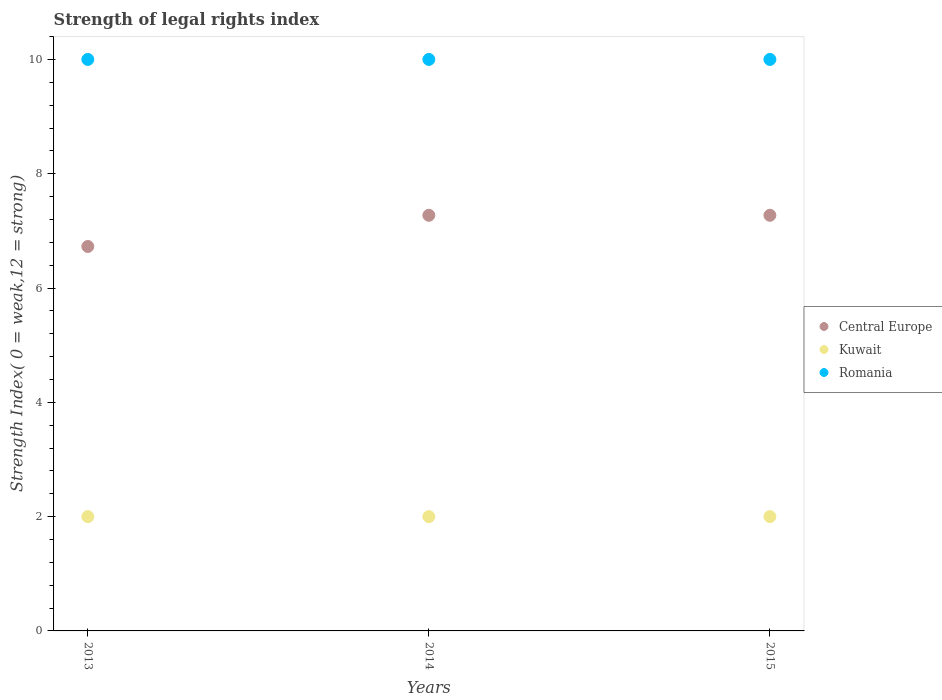What is the strength index in Central Europe in 2014?
Your response must be concise. 7.27. Across all years, what is the maximum strength index in Romania?
Provide a short and direct response. 10. Across all years, what is the minimum strength index in Romania?
Provide a short and direct response. 10. In which year was the strength index in Central Europe maximum?
Ensure brevity in your answer.  2014. What is the total strength index in Central Europe in the graph?
Your response must be concise. 21.27. What is the difference between the strength index in Romania in 2013 and that in 2015?
Your answer should be very brief. 0. What is the difference between the strength index in Kuwait in 2015 and the strength index in Romania in 2013?
Make the answer very short. -8. What is the average strength index in Kuwait per year?
Your answer should be compact. 2. In the year 2015, what is the difference between the strength index in Romania and strength index in Kuwait?
Provide a short and direct response. 8. What is the ratio of the strength index in Romania in 2014 to that in 2015?
Provide a succinct answer. 1. What is the difference between the highest and the second highest strength index in Kuwait?
Keep it short and to the point. 0. What is the difference between the highest and the lowest strength index in Romania?
Offer a terse response. 0. Is the sum of the strength index in Romania in 2013 and 2015 greater than the maximum strength index in Central Europe across all years?
Provide a succinct answer. Yes. Does the strength index in Kuwait monotonically increase over the years?
Provide a succinct answer. No. How many dotlines are there?
Give a very brief answer. 3. How many years are there in the graph?
Make the answer very short. 3. What is the difference between two consecutive major ticks on the Y-axis?
Offer a very short reply. 2. Does the graph contain grids?
Offer a very short reply. No. Where does the legend appear in the graph?
Provide a succinct answer. Center right. How are the legend labels stacked?
Your answer should be compact. Vertical. What is the title of the graph?
Make the answer very short. Strength of legal rights index. Does "Ecuador" appear as one of the legend labels in the graph?
Your answer should be compact. No. What is the label or title of the Y-axis?
Ensure brevity in your answer.  Strength Index( 0 = weak,12 = strong). What is the Strength Index( 0 = weak,12 = strong) in Central Europe in 2013?
Ensure brevity in your answer.  6.73. What is the Strength Index( 0 = weak,12 = strong) of Kuwait in 2013?
Ensure brevity in your answer.  2. What is the Strength Index( 0 = weak,12 = strong) of Central Europe in 2014?
Ensure brevity in your answer.  7.27. What is the Strength Index( 0 = weak,12 = strong) of Romania in 2014?
Keep it short and to the point. 10. What is the Strength Index( 0 = weak,12 = strong) in Central Europe in 2015?
Your answer should be compact. 7.27. Across all years, what is the maximum Strength Index( 0 = weak,12 = strong) in Central Europe?
Your answer should be compact. 7.27. Across all years, what is the maximum Strength Index( 0 = weak,12 = strong) in Romania?
Your answer should be compact. 10. Across all years, what is the minimum Strength Index( 0 = weak,12 = strong) of Central Europe?
Offer a very short reply. 6.73. Across all years, what is the minimum Strength Index( 0 = weak,12 = strong) in Kuwait?
Offer a very short reply. 2. Across all years, what is the minimum Strength Index( 0 = weak,12 = strong) of Romania?
Your answer should be compact. 10. What is the total Strength Index( 0 = weak,12 = strong) of Central Europe in the graph?
Give a very brief answer. 21.27. What is the total Strength Index( 0 = weak,12 = strong) of Kuwait in the graph?
Provide a succinct answer. 6. What is the difference between the Strength Index( 0 = weak,12 = strong) of Central Europe in 2013 and that in 2014?
Give a very brief answer. -0.55. What is the difference between the Strength Index( 0 = weak,12 = strong) in Kuwait in 2013 and that in 2014?
Provide a short and direct response. 0. What is the difference between the Strength Index( 0 = weak,12 = strong) of Romania in 2013 and that in 2014?
Offer a very short reply. 0. What is the difference between the Strength Index( 0 = weak,12 = strong) of Central Europe in 2013 and that in 2015?
Your answer should be compact. -0.55. What is the difference between the Strength Index( 0 = weak,12 = strong) in Central Europe in 2014 and that in 2015?
Provide a short and direct response. 0. What is the difference between the Strength Index( 0 = weak,12 = strong) of Central Europe in 2013 and the Strength Index( 0 = weak,12 = strong) of Kuwait in 2014?
Your answer should be compact. 4.73. What is the difference between the Strength Index( 0 = weak,12 = strong) in Central Europe in 2013 and the Strength Index( 0 = weak,12 = strong) in Romania in 2014?
Provide a succinct answer. -3.27. What is the difference between the Strength Index( 0 = weak,12 = strong) in Central Europe in 2013 and the Strength Index( 0 = weak,12 = strong) in Kuwait in 2015?
Your answer should be compact. 4.73. What is the difference between the Strength Index( 0 = weak,12 = strong) of Central Europe in 2013 and the Strength Index( 0 = weak,12 = strong) of Romania in 2015?
Give a very brief answer. -3.27. What is the difference between the Strength Index( 0 = weak,12 = strong) in Kuwait in 2013 and the Strength Index( 0 = weak,12 = strong) in Romania in 2015?
Your answer should be compact. -8. What is the difference between the Strength Index( 0 = weak,12 = strong) of Central Europe in 2014 and the Strength Index( 0 = weak,12 = strong) of Kuwait in 2015?
Your response must be concise. 5.27. What is the difference between the Strength Index( 0 = weak,12 = strong) of Central Europe in 2014 and the Strength Index( 0 = weak,12 = strong) of Romania in 2015?
Provide a short and direct response. -2.73. What is the difference between the Strength Index( 0 = weak,12 = strong) of Kuwait in 2014 and the Strength Index( 0 = weak,12 = strong) of Romania in 2015?
Your answer should be very brief. -8. What is the average Strength Index( 0 = weak,12 = strong) of Central Europe per year?
Provide a succinct answer. 7.09. In the year 2013, what is the difference between the Strength Index( 0 = weak,12 = strong) in Central Europe and Strength Index( 0 = weak,12 = strong) in Kuwait?
Make the answer very short. 4.73. In the year 2013, what is the difference between the Strength Index( 0 = weak,12 = strong) in Central Europe and Strength Index( 0 = weak,12 = strong) in Romania?
Provide a succinct answer. -3.27. In the year 2014, what is the difference between the Strength Index( 0 = weak,12 = strong) in Central Europe and Strength Index( 0 = weak,12 = strong) in Kuwait?
Provide a succinct answer. 5.27. In the year 2014, what is the difference between the Strength Index( 0 = weak,12 = strong) of Central Europe and Strength Index( 0 = weak,12 = strong) of Romania?
Give a very brief answer. -2.73. In the year 2014, what is the difference between the Strength Index( 0 = weak,12 = strong) in Kuwait and Strength Index( 0 = weak,12 = strong) in Romania?
Give a very brief answer. -8. In the year 2015, what is the difference between the Strength Index( 0 = weak,12 = strong) in Central Europe and Strength Index( 0 = weak,12 = strong) in Kuwait?
Your answer should be compact. 5.27. In the year 2015, what is the difference between the Strength Index( 0 = weak,12 = strong) of Central Europe and Strength Index( 0 = weak,12 = strong) of Romania?
Your response must be concise. -2.73. In the year 2015, what is the difference between the Strength Index( 0 = weak,12 = strong) of Kuwait and Strength Index( 0 = weak,12 = strong) of Romania?
Offer a very short reply. -8. What is the ratio of the Strength Index( 0 = weak,12 = strong) in Central Europe in 2013 to that in 2014?
Make the answer very short. 0.93. What is the ratio of the Strength Index( 0 = weak,12 = strong) in Central Europe in 2013 to that in 2015?
Provide a short and direct response. 0.93. What is the ratio of the Strength Index( 0 = weak,12 = strong) in Kuwait in 2013 to that in 2015?
Ensure brevity in your answer.  1. What is the ratio of the Strength Index( 0 = weak,12 = strong) of Romania in 2013 to that in 2015?
Offer a terse response. 1. What is the ratio of the Strength Index( 0 = weak,12 = strong) in Central Europe in 2014 to that in 2015?
Make the answer very short. 1. What is the ratio of the Strength Index( 0 = weak,12 = strong) of Romania in 2014 to that in 2015?
Keep it short and to the point. 1. What is the difference between the highest and the second highest Strength Index( 0 = weak,12 = strong) in Kuwait?
Provide a short and direct response. 0. What is the difference between the highest and the second highest Strength Index( 0 = weak,12 = strong) of Romania?
Provide a short and direct response. 0. What is the difference between the highest and the lowest Strength Index( 0 = weak,12 = strong) of Central Europe?
Make the answer very short. 0.55. What is the difference between the highest and the lowest Strength Index( 0 = weak,12 = strong) of Kuwait?
Provide a succinct answer. 0. 